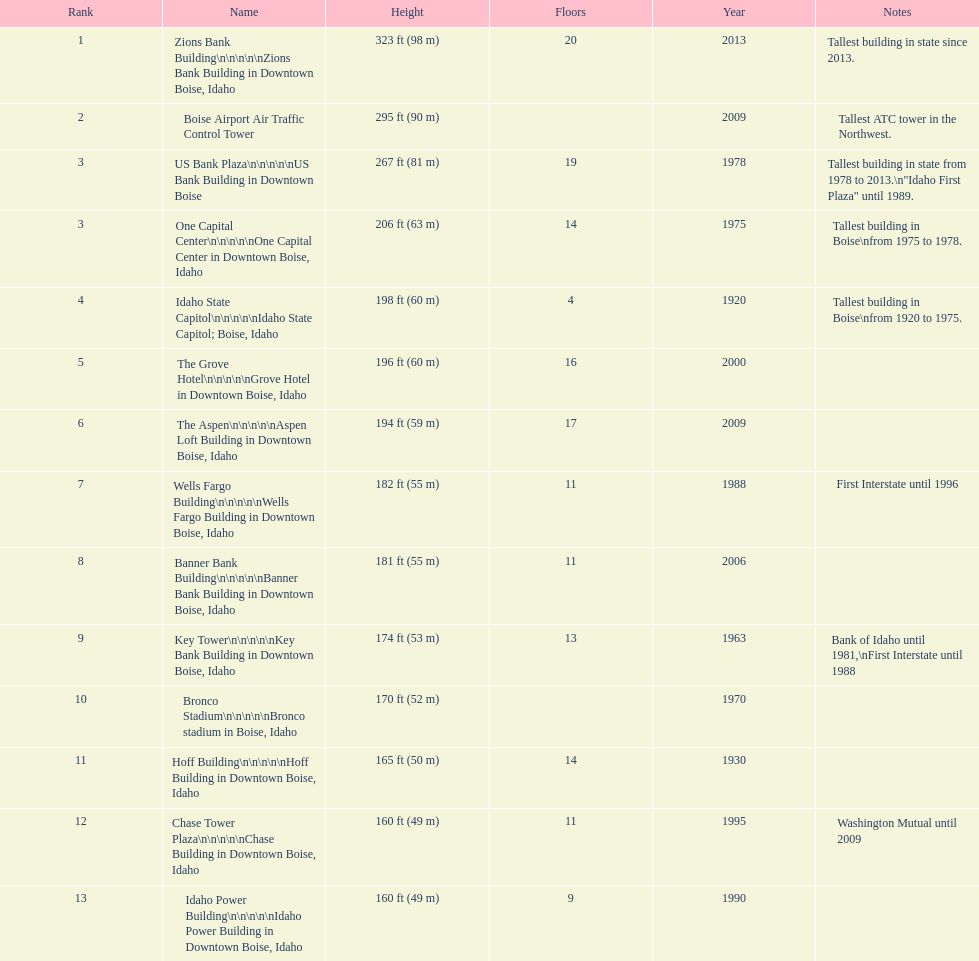Is the bronco stadium above or below 150 ft? Above. 